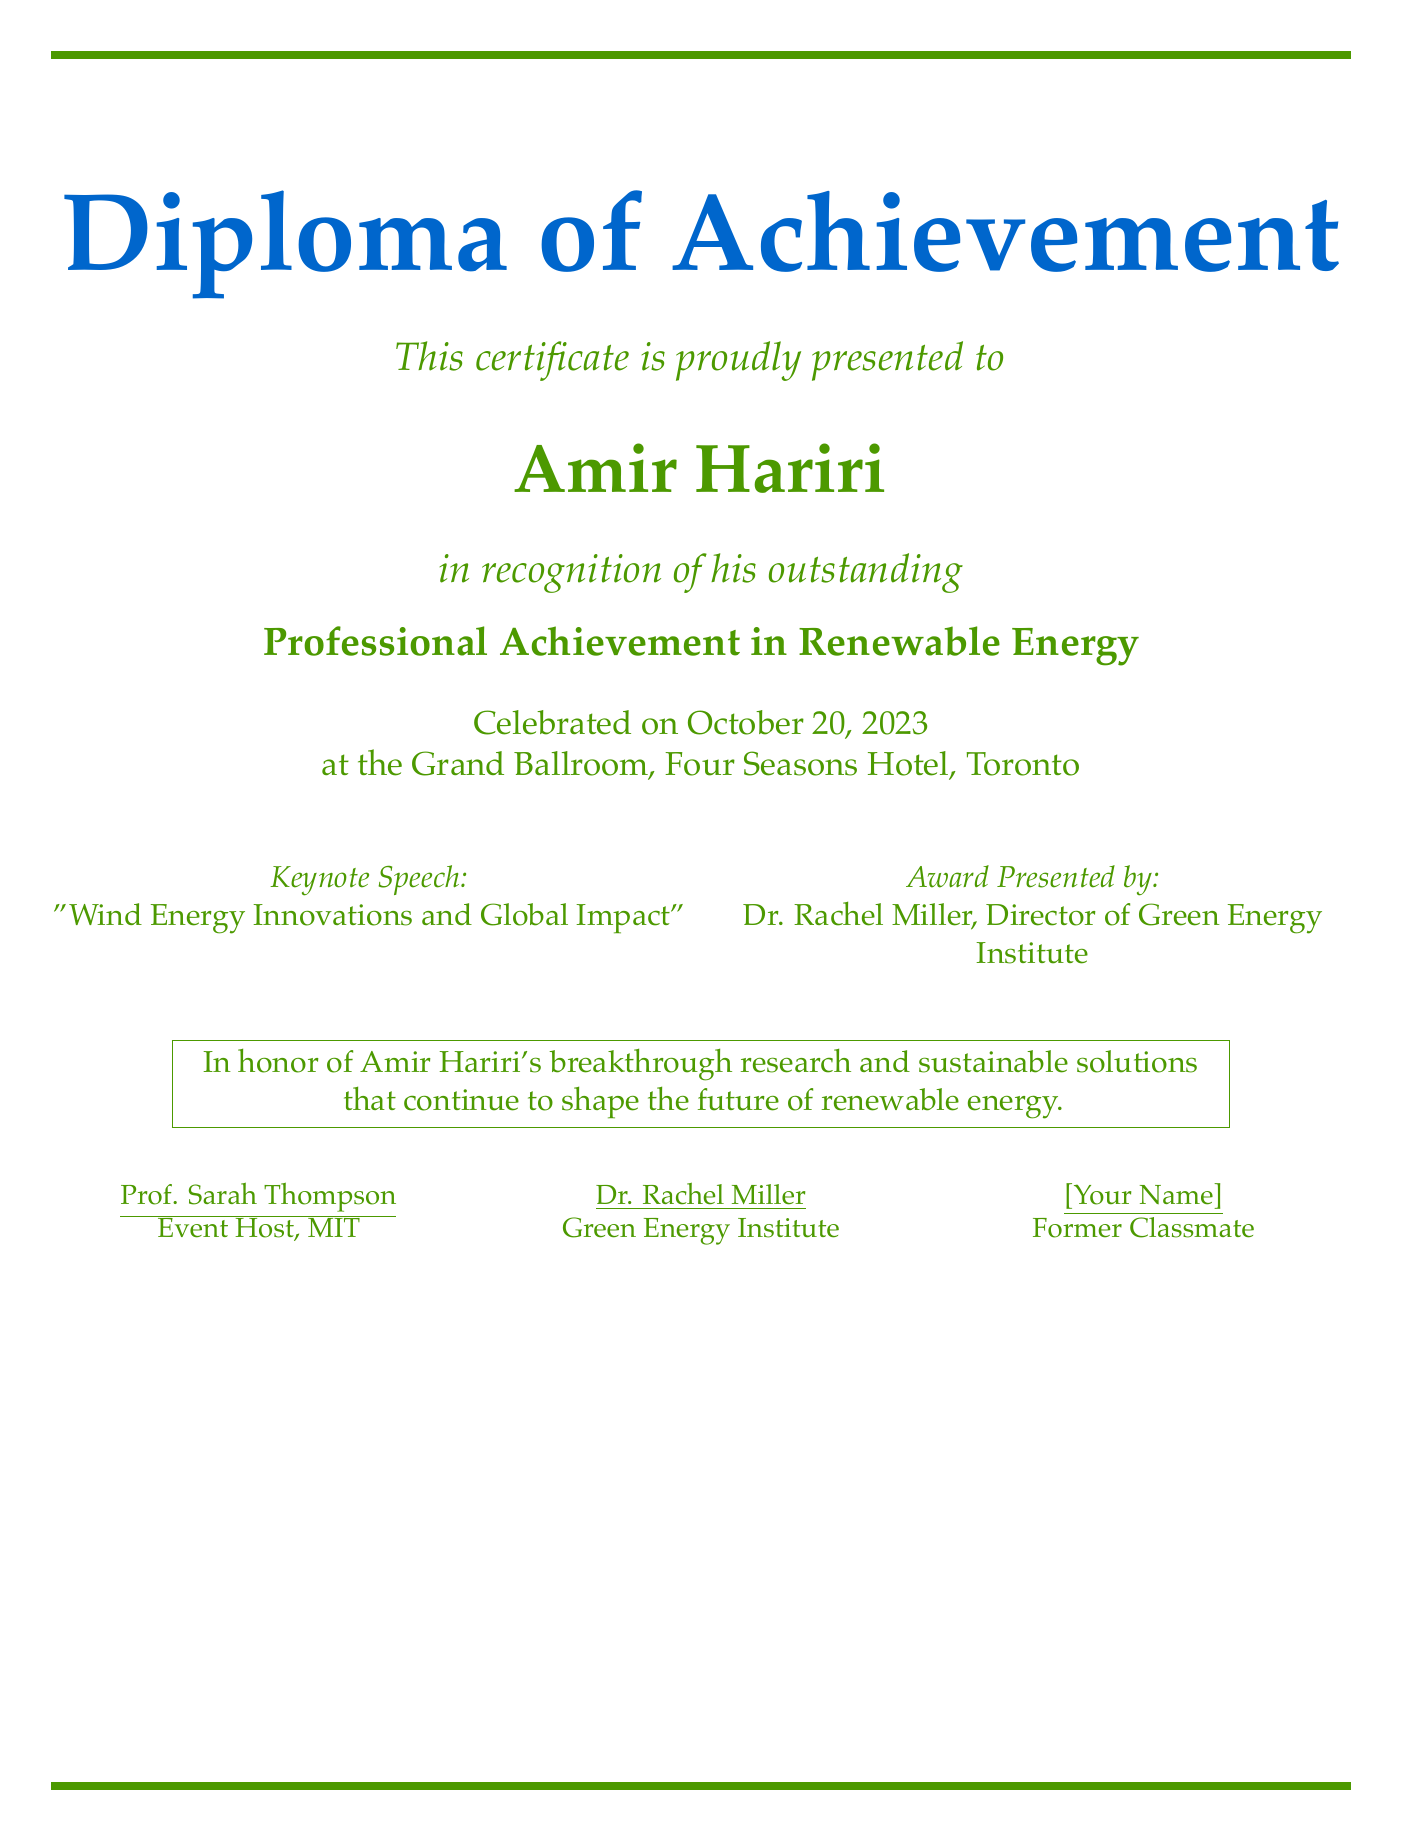What is the title of the diploma? The title of the diploma is presented prominently in the document.
Answer: Diploma of Achievement Who is the recipient of the diploma? The recipient's name is stated directly after the title in the document.
Answer: Amir Hariri What was the professional achievement recognized? The document specifies the focus of the achievement.
Answer: Professional Achievement in Renewable Energy What is the date of the celebration? The date is mentioned under the recipient's name in the document.
Answer: October 20, 2023 Where was the event held? The venue of the celebration is listed in the document.
Answer: Grand Ballroom, Four Seasons Hotel, Toronto Who presented the award? The award presenter’s name is revealed in the section detailing key event participants.
Answer: Dr. Rachel Miller What is the title of the keynote speech? The title of the keynote speech is clearly outlined in the document.
Answer: Wind Energy Innovations and Global Impact Who is the event host? The event host's name is found in the section outlining key event participants.
Answer: Prof. Sarah Thompson How many people are listed as participants? The document shows three notable figures engaged in the event.
Answer: Three 